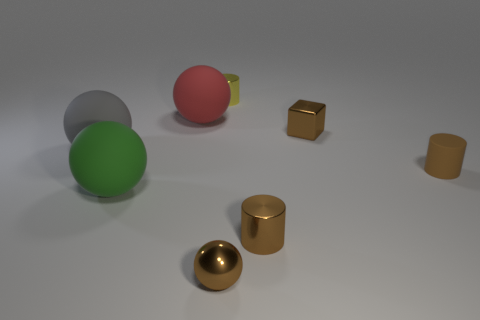Is there any other thing that is the same size as the yellow metal cylinder?
Your response must be concise. Yes. What number of other objects are there of the same color as the small sphere?
Ensure brevity in your answer.  3. Are there fewer small brown metal things that are to the right of the metal block than large rubber objects right of the big green sphere?
Your response must be concise. Yes. What number of small brown cylinders are there?
Your answer should be compact. 2. Is there anything else that is the same material as the brown ball?
Keep it short and to the point. Yes. What is the material of the green object that is the same shape as the gray rubber object?
Provide a short and direct response. Rubber. Are there fewer green rubber objects behind the tiny yellow cylinder than matte objects?
Your answer should be compact. Yes. There is a big object that is in front of the big gray matte sphere; does it have the same shape as the tiny yellow shiny thing?
Your answer should be very brief. No. Is there anything else of the same color as the shiny cube?
Keep it short and to the point. Yes. There is a red object that is the same material as the green ball; what is its size?
Ensure brevity in your answer.  Large. 